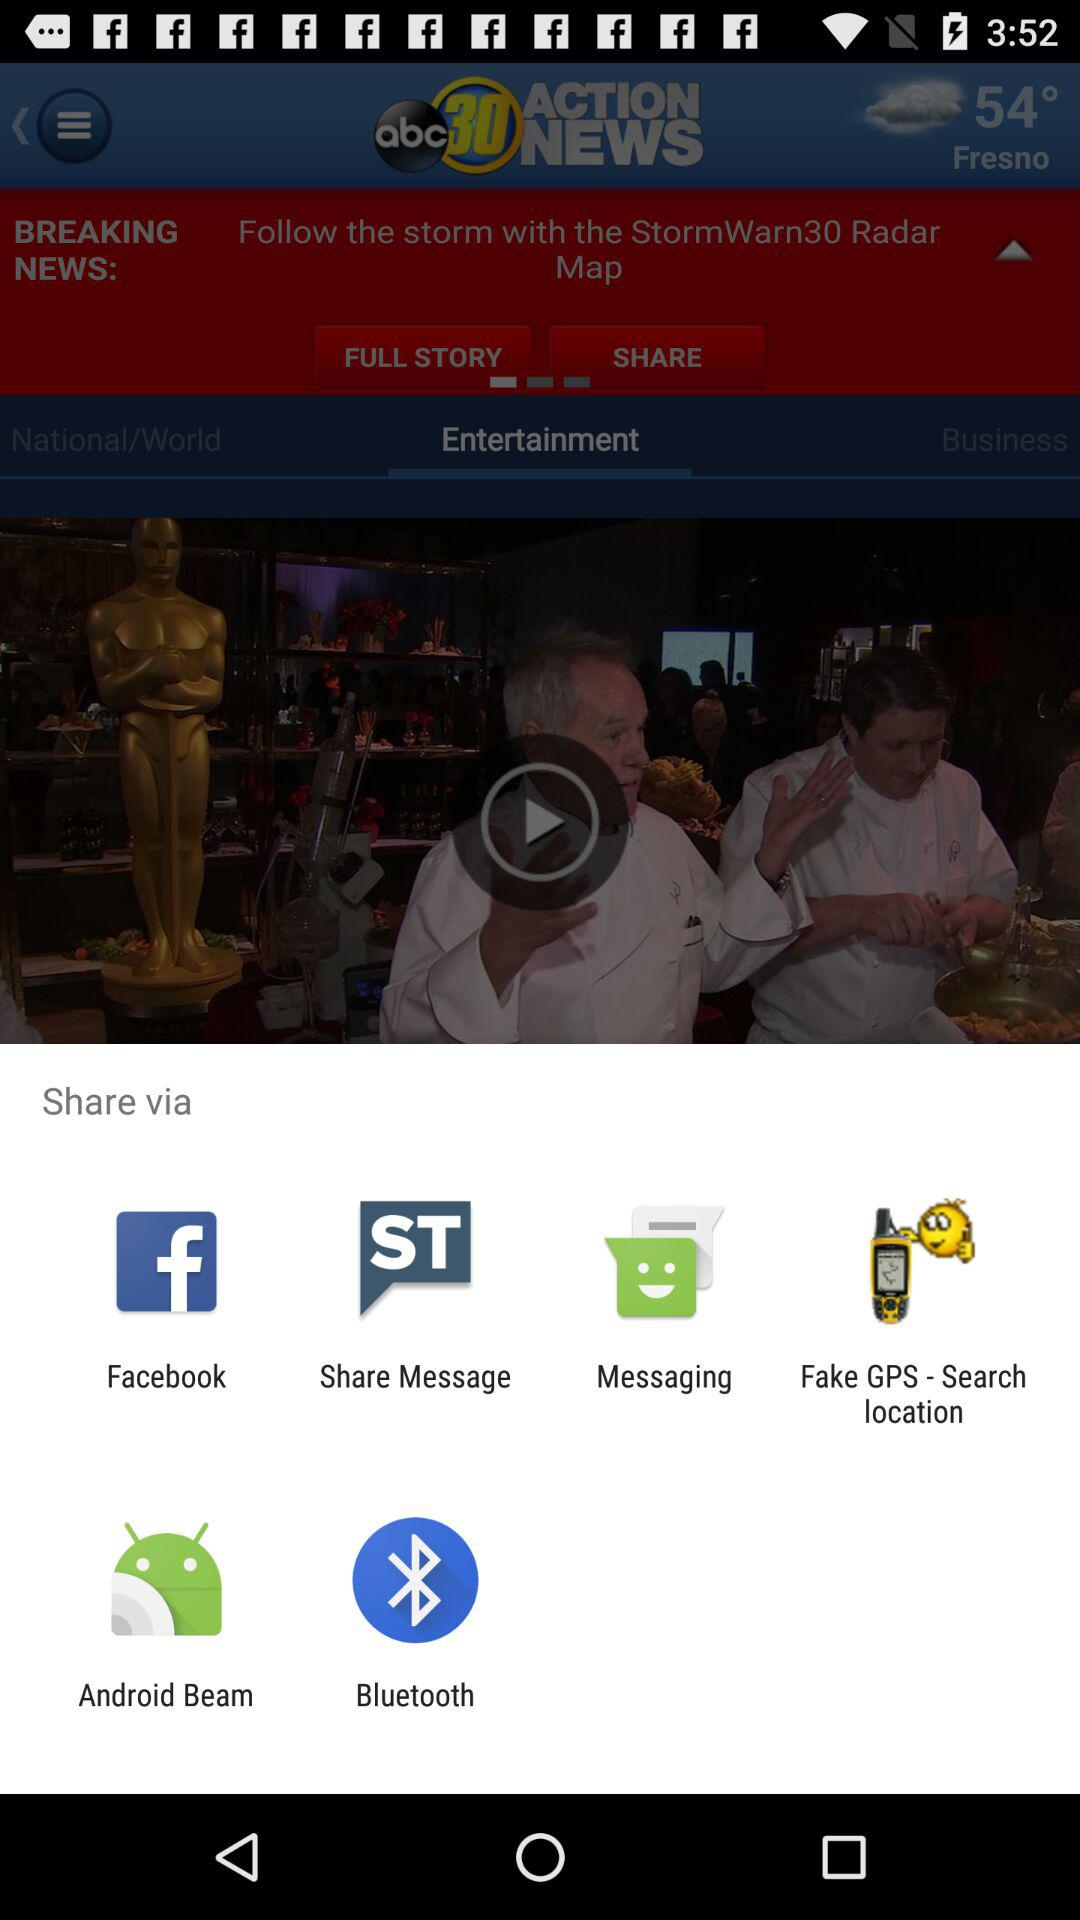What applications can we use to share videos? The applications are "Facebook", "Share Message", "Messaging", "Fake GPS - Search location", "Android Beam" and "Bluetooth". 